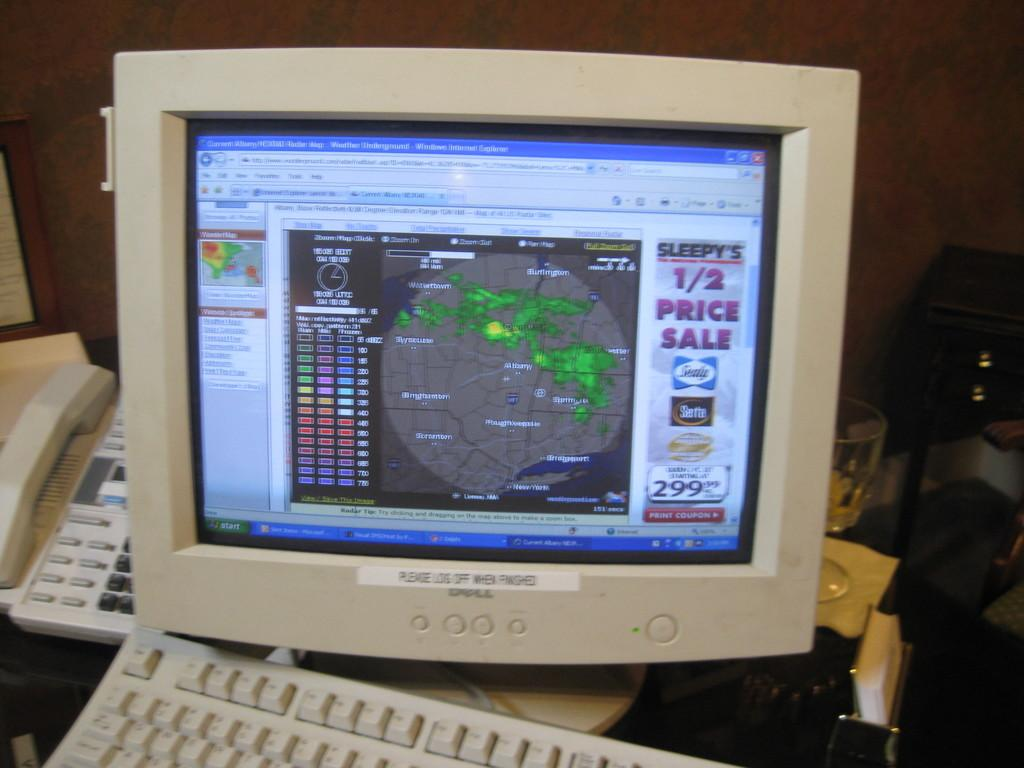<image>
Give a short and clear explanation of the subsequent image. a dell computer with an internet explorer tab open 